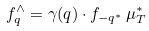<formula> <loc_0><loc_0><loc_500><loc_500>f _ { q } ^ { \wedge } = \gamma ( q ) \cdot f _ { - q ^ { * } } \, \mu _ { T } ^ { * }</formula> 